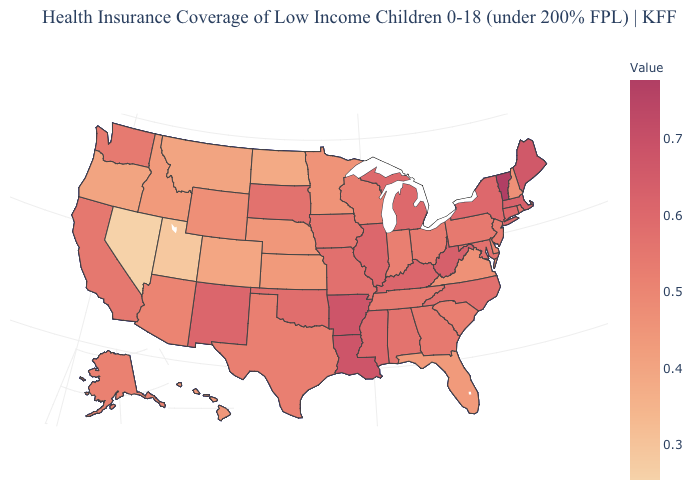Is the legend a continuous bar?
Write a very short answer. Yes. Is the legend a continuous bar?
Answer briefly. Yes. Does Kentucky have a higher value than Arkansas?
Quick response, please. No. Does New Mexico have the highest value in the West?
Quick response, please. Yes. Does Ohio have the highest value in the USA?
Give a very brief answer. No. Among the states that border South Dakota , does North Dakota have the lowest value?
Write a very short answer. Yes. Among the states that border Arizona , which have the highest value?
Concise answer only. New Mexico. 